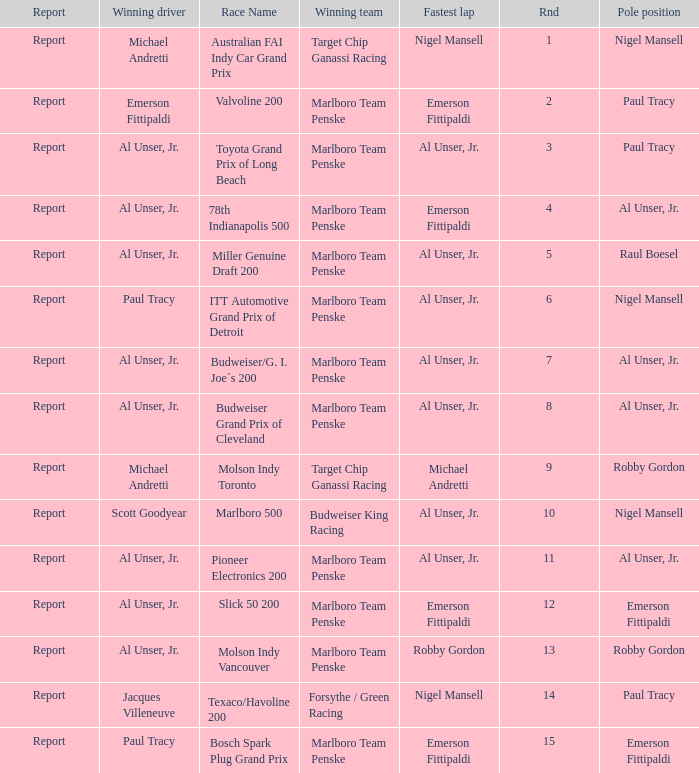Who did the fastest lap in the race won by Paul Tracy, with Emerson Fittipaldi at the pole position? Emerson Fittipaldi. 